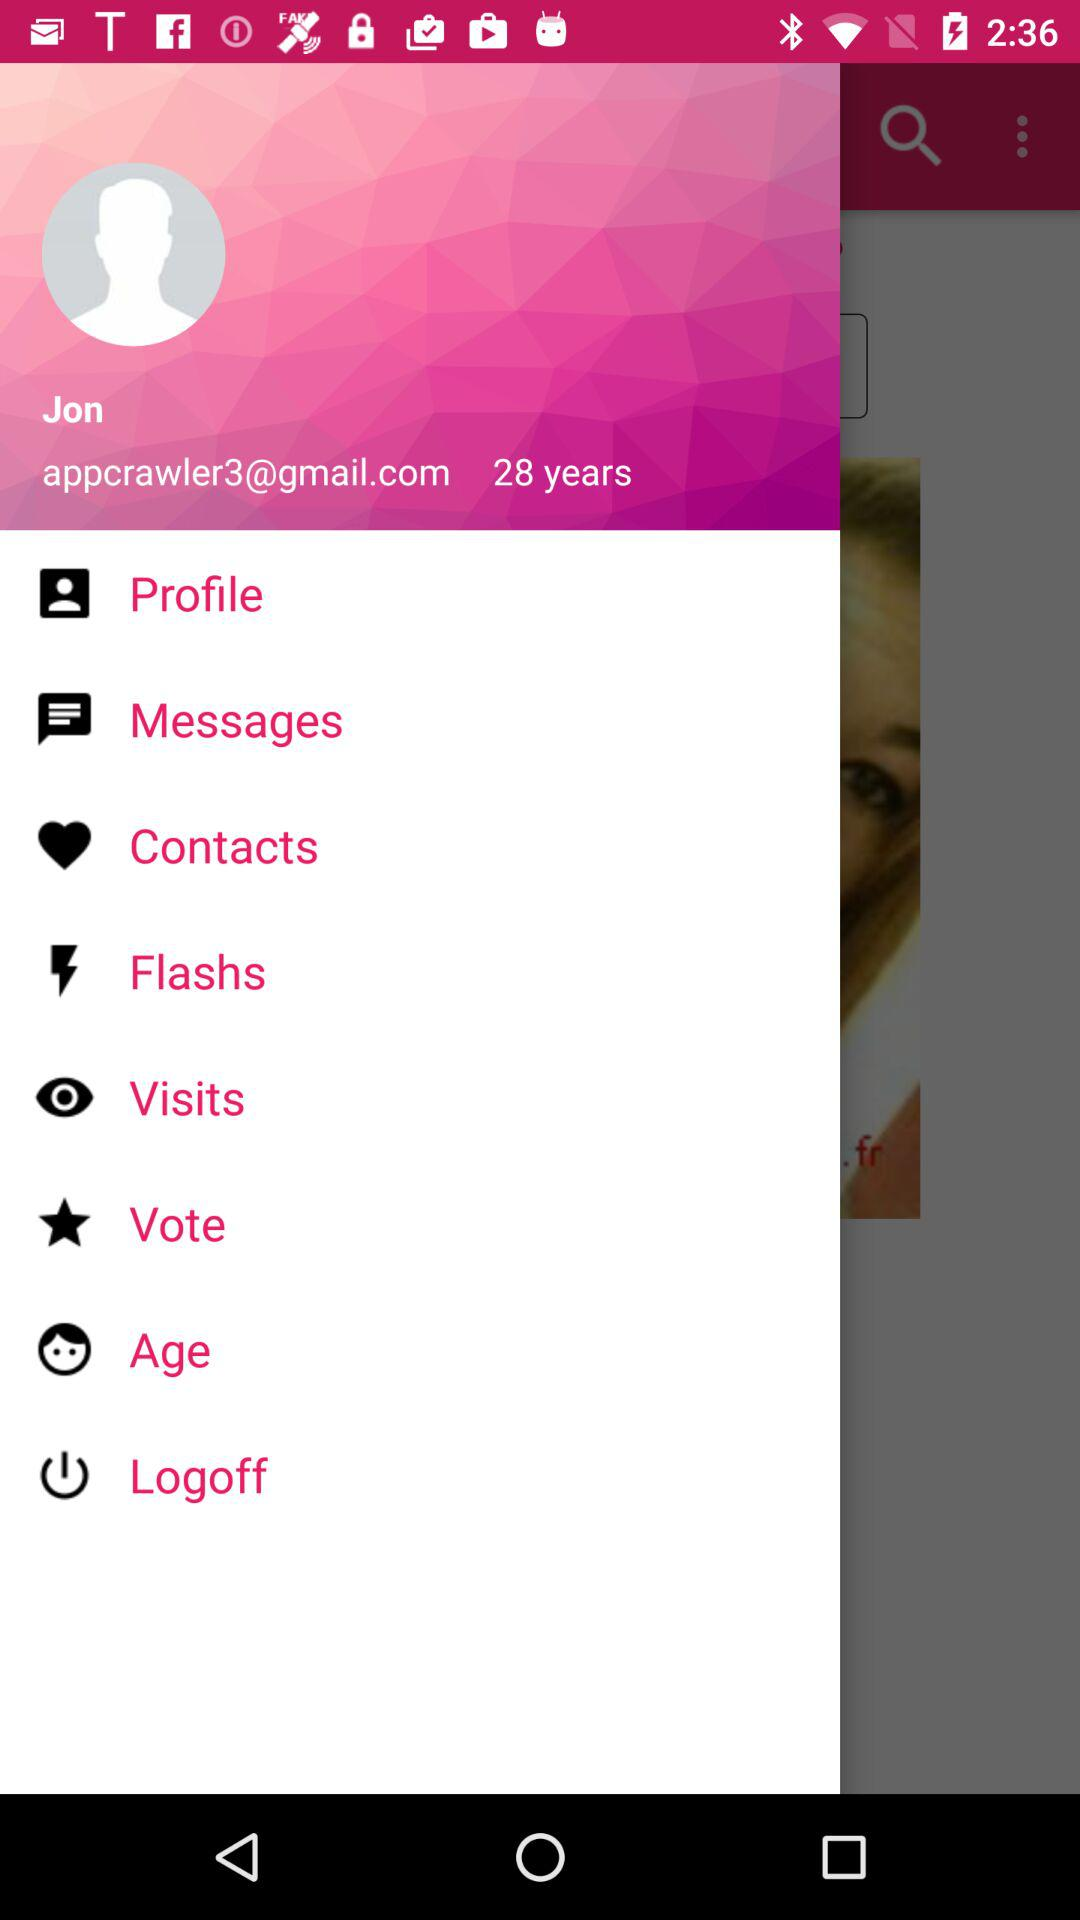What is the age of Jon? The age of Jon is 28 years. 